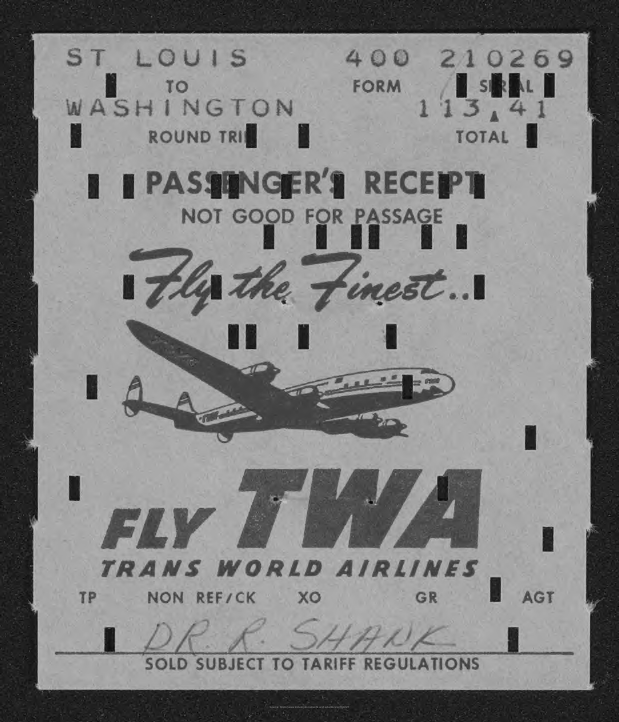Give some essential details in this illustration. The passenger's name mentioned in the receipt is Dr. R. Shank.. 